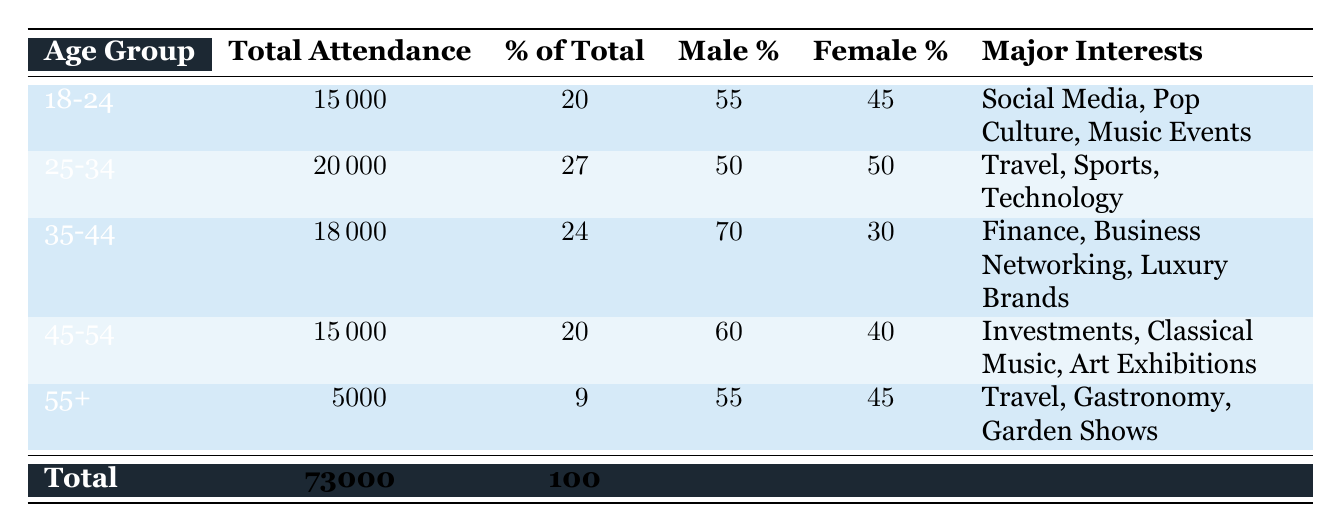What is the total attendance for the age group 25-34? The total attendance for the age group 25-34 is listed directly in the table under the column "Total Attendance." It shows a value of 20000.
Answer: 20000 What percentage of the total attendance does the age group 18-24 represent? The percentage of total attendance for the age group 18-24 is provided in the column "% of Total." This age group has a percentage of 20.
Answer: 20 Which age group has the highest percentage of males? By comparing the "Male %" column across all age groups, the age group 35-44 has the highest percentage at 70.
Answer: 35-44 What is the total attendance for all age groups combined? The total attendance across all age groups is calculated by summing the "Total Attendance" values: 15000 + 20000 + 18000 + 15000 + 5000 = 73000.
Answer: 73000 Is it true that the majority of attendees in the age group 45-54 are male? To determine this, the "Male %" for the age group 45-54 is 60, which is greater than 50, indicating that the majority of attendees in this group are indeed male.
Answer: Yes What is the average attendance across age groups aged 35-44 and 45-54? The attendance values for these age groups are 18000 and 15000, respectively. The average is calculated by taking the sum (18000 + 15000 = 33000) and dividing by 2, resulting in an average of 16500.
Answer: 16500 What are the major interests of the age group 55+? The "Major Interests" for the age group 55+ are listed as "Travel, Gastronomy, Garden Shows," which is provided directly in the table.
Answer: Travel, Gastronomy, Garden Shows Which age group has the least total attendance? By checking the "Total Attendance" values for all age groups, the age group 55+ has the lowest attendance with a value of 5000.
Answer: 55+ How do the female percentages compare between the age groups 25-34 and 35-44? The "Female %" for 25-34 is 50, while for 35-44 it is 30. Thus, females comprise a larger portion of the 25-34 age group compared to the 35-44 age group.
Answer: 25-34 has a higher female percentage 